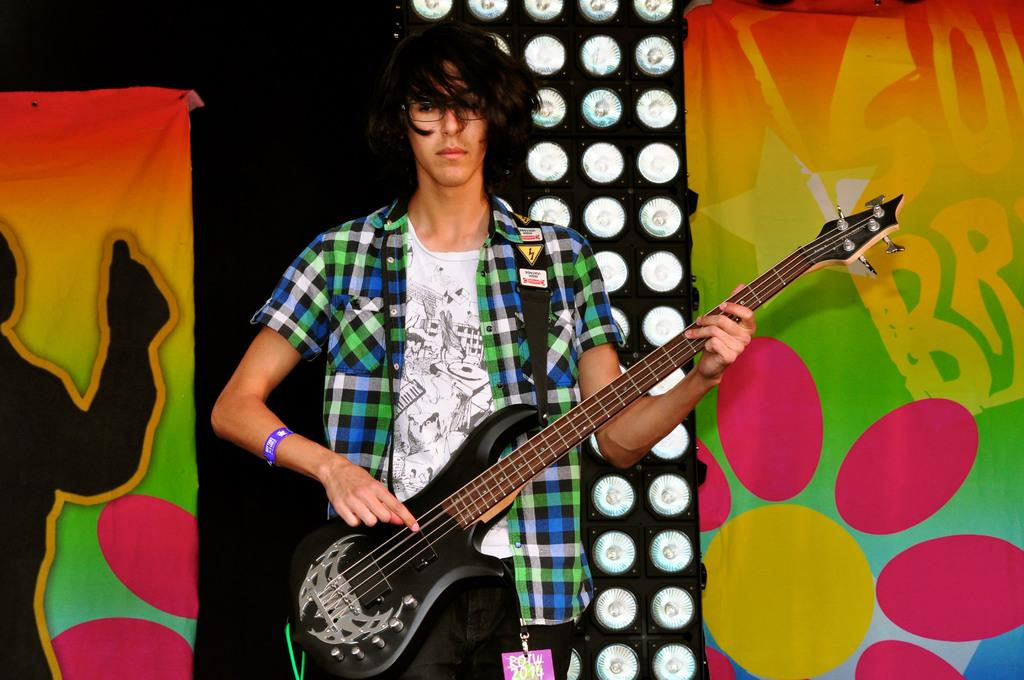Who is the main subject in the image? There is a person in the center of the image. What is the person holding in the image? The person is holding a guitar. What can be seen in the background of the image? There are lights and a banner visible in the background. What type of silk fabric is draped over the person's shoulders in the image? There is no silk fabric present in the image; the person is holding a guitar. 